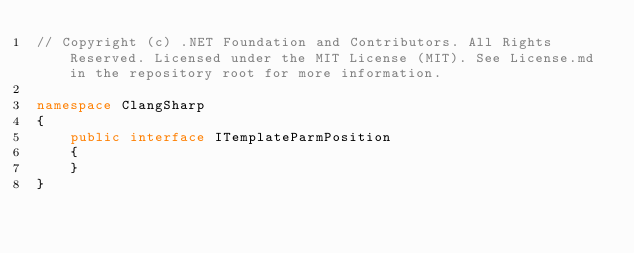<code> <loc_0><loc_0><loc_500><loc_500><_C#_>// Copyright (c) .NET Foundation and Contributors. All Rights Reserved. Licensed under the MIT License (MIT). See License.md in the repository root for more information.

namespace ClangSharp
{
    public interface ITemplateParmPosition
    {
    }
}
</code> 